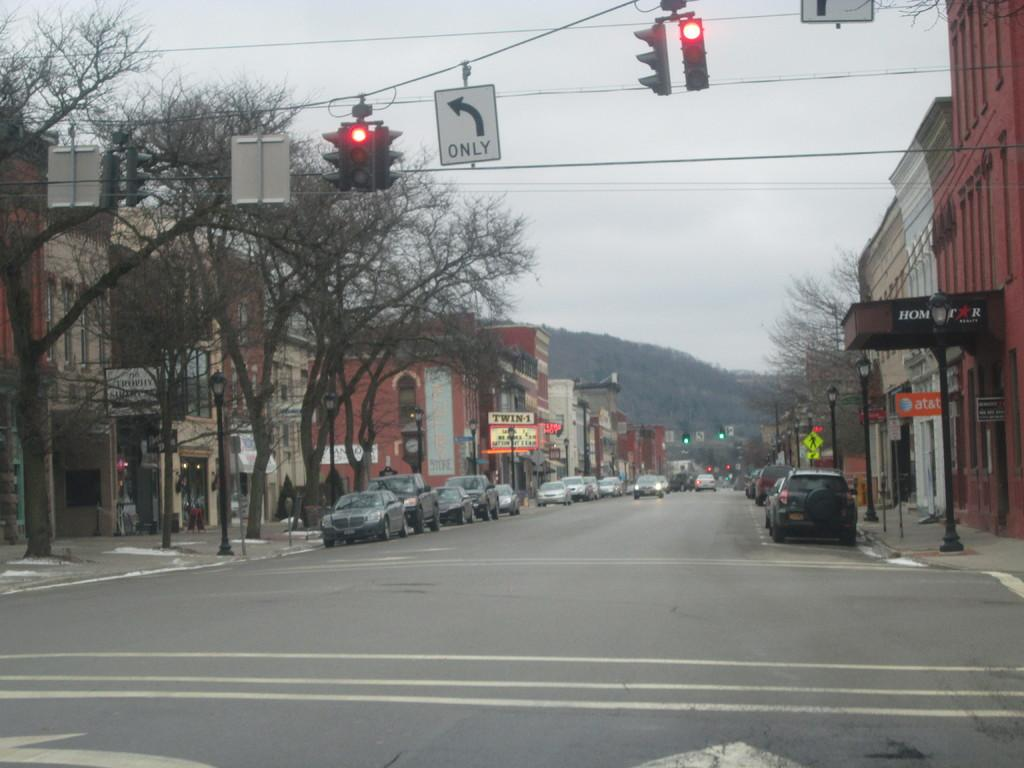<image>
Relay a brief, clear account of the picture shown. Two traffic lights are red for both going straight and turning left only. 